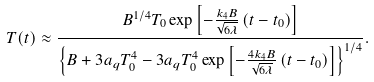<formula> <loc_0><loc_0><loc_500><loc_500>T ( t ) \approx \frac { B ^ { 1 / 4 } T _ { 0 } \exp \left [ - \frac { k _ { 4 } B } { \sqrt { 6 \lambda } } \left ( t - t _ { 0 } \right ) \right ] } { \left \{ B + 3 a _ { q } T _ { 0 } ^ { 4 } - 3 a _ { q } T _ { 0 } ^ { 4 } \exp \left [ - \frac { 4 k _ { 4 } B } { \sqrt { 6 \lambda } } \left ( t - t _ { 0 } \right ) \right ] \right \} ^ { 1 / 4 } } .</formula> 